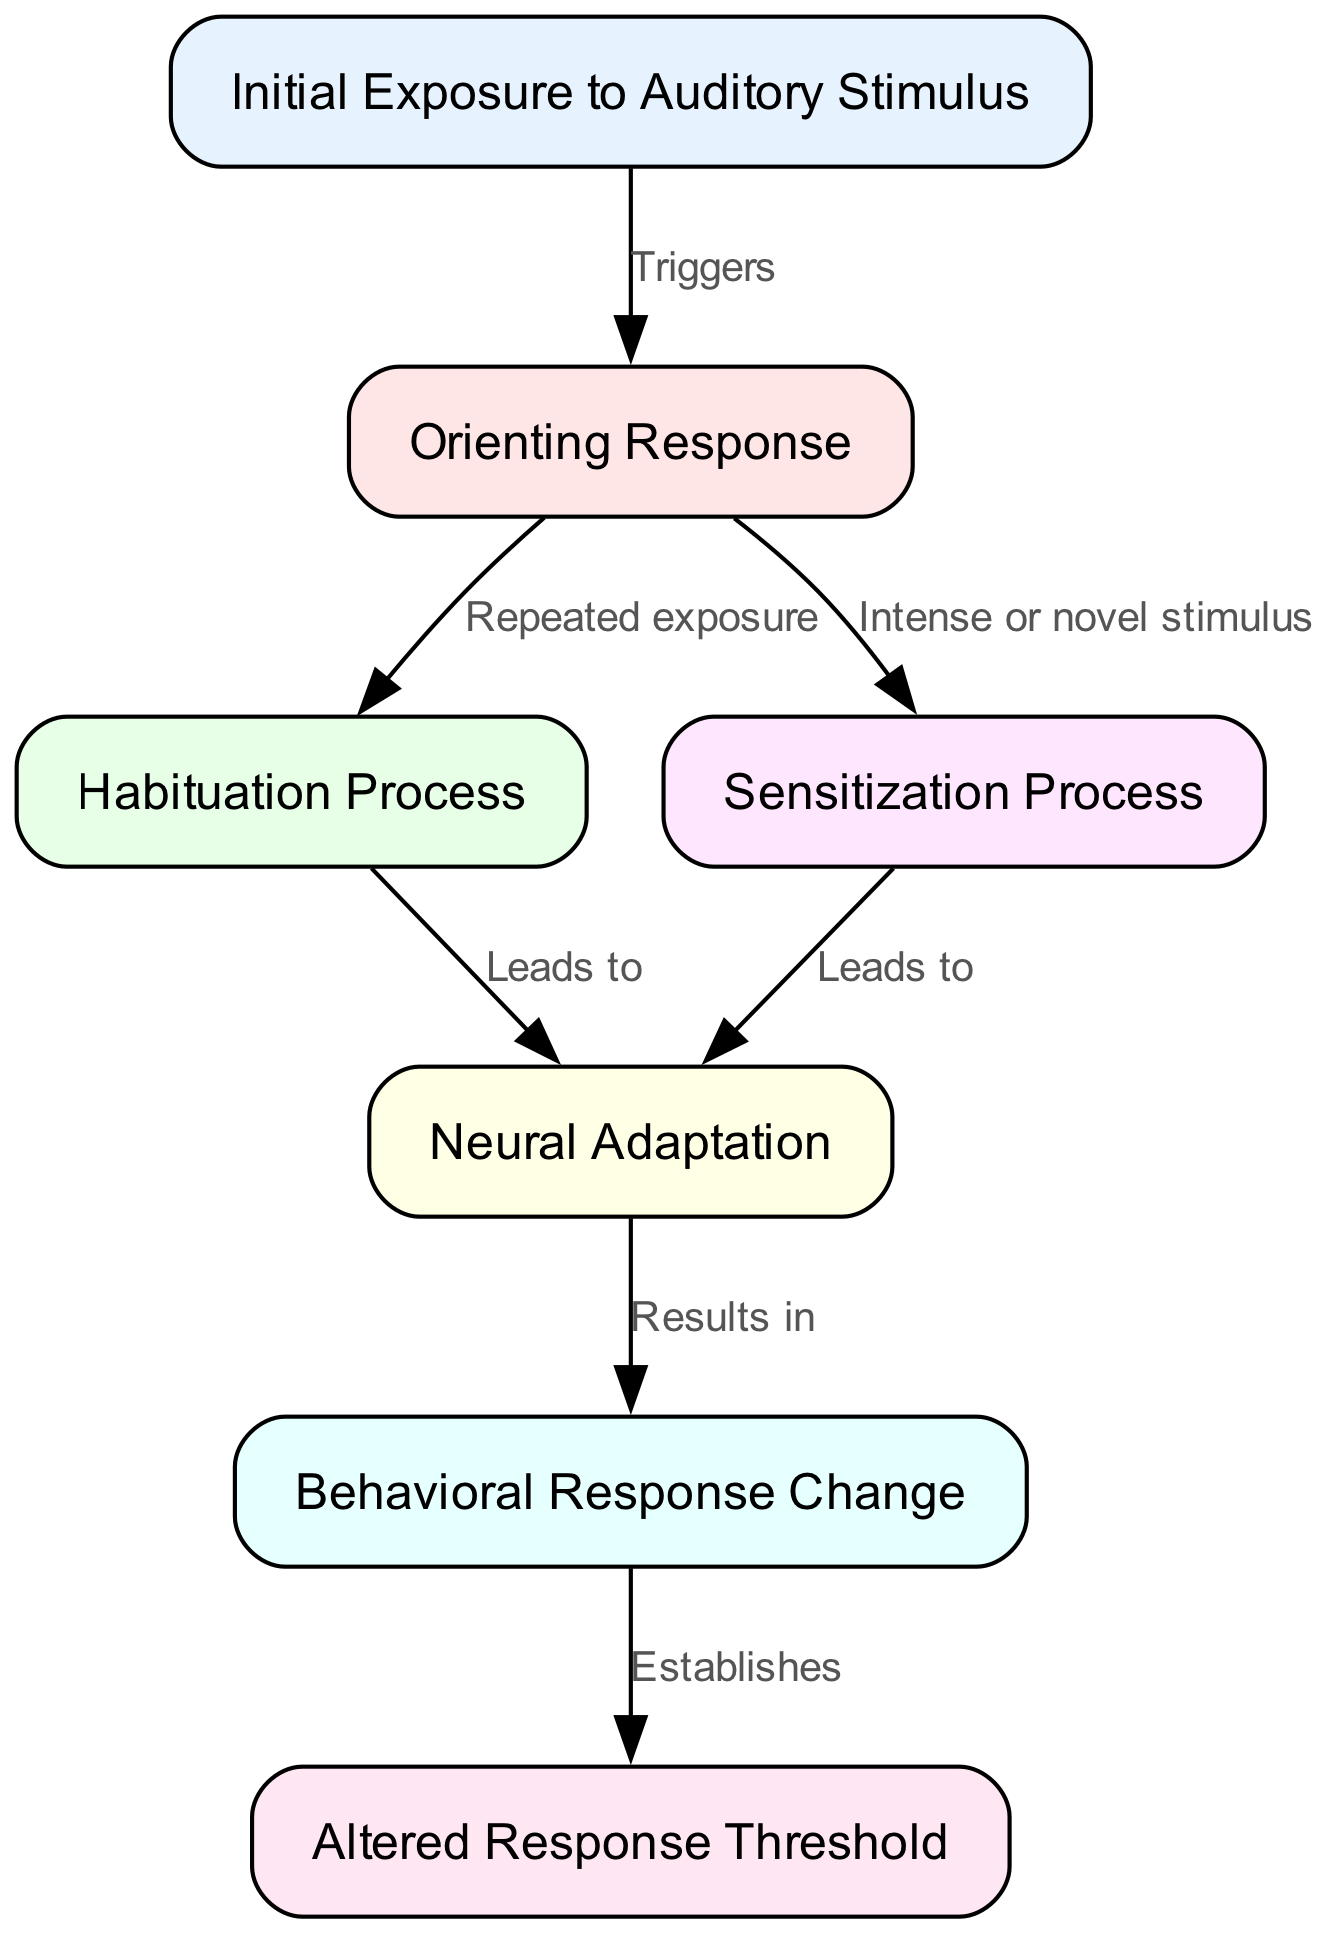What is the first node in the diagram? The first node in the diagram is labeled "Initial Exposure to Auditory Stimulus," which represents the starting point of the habituation and sensitization process.
Answer: Initial Exposure to Auditory Stimulus How many edges are present in the diagram? The diagram contains a total of 7 edges, indicating the connections and relationships between different stages of the habituation and sensitization processes.
Answer: 7 What type of response does the "Orienting Response" lead to? The "Orienting Response" can lead to either the "Habituation Process" through repeated exposure or the "Sensitization Process" through intense or novel stimuli, establishing two potential pathways.
Answer: Habituation Process or Sensitization Process Which node results from the "Neural Adaptation"? The "Neural Adaptation" leads to the "Behavioral Response Change," representing the outcome of neurophysiological adjustments in response to auditory stimuli.
Answer: Behavioral Response Change What establishes the "Altered Response Threshold"? The "Altered Response Threshold" is established by the connection from the "Behavioral Response Change," resulting from previous processing stages, reflecting changes in behavioral responses to future stimuli.
Answer: Behavioral Response Change 